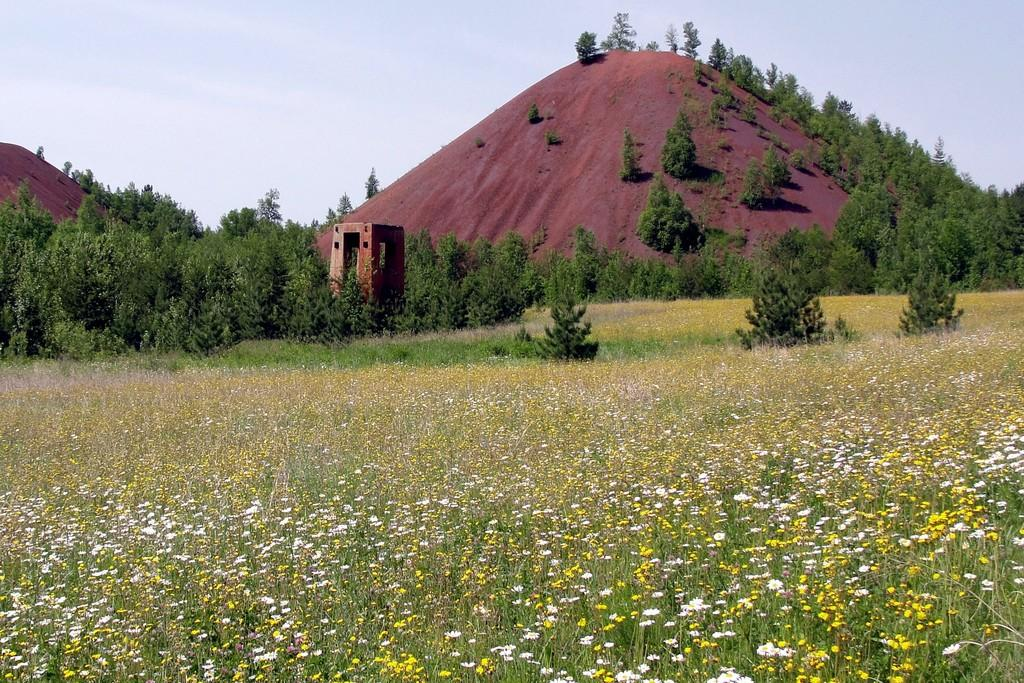What type of landscape is depicted at the bottom side of the image? There is a flower field at the bottom side of the image. What other natural elements can be seen in the image? There is greenery in the image. Can you describe any structures visible in the background? There is a small house in the background area of the image. Is there any poison visible in the image? There is no poison present in the image. Can you describe the maid in the image? There is no maid present in the image. 